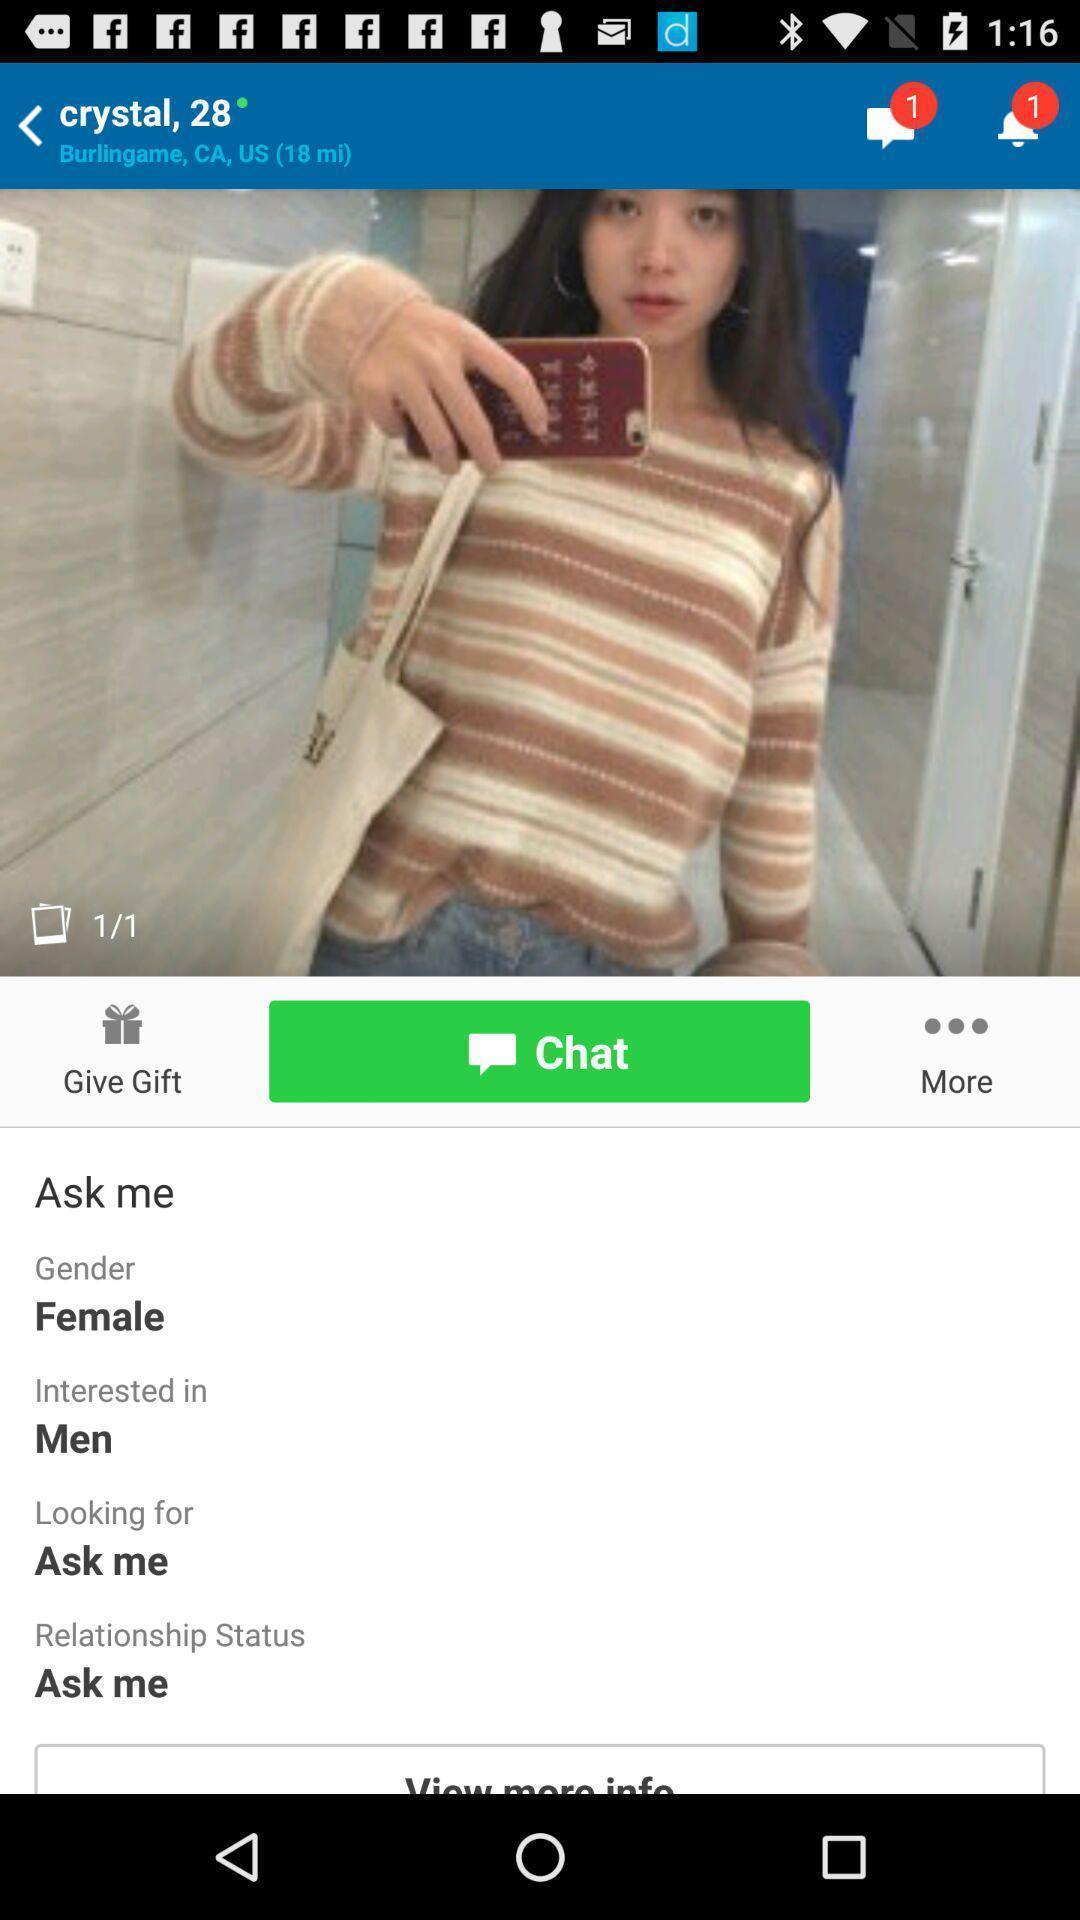Provide a description of this screenshot. Screen showing page of an social application. 